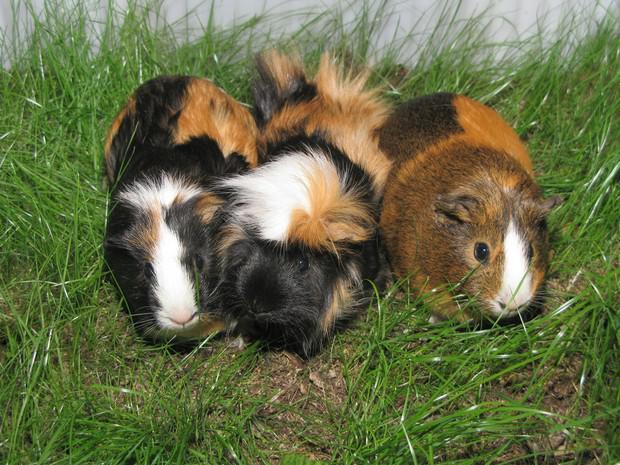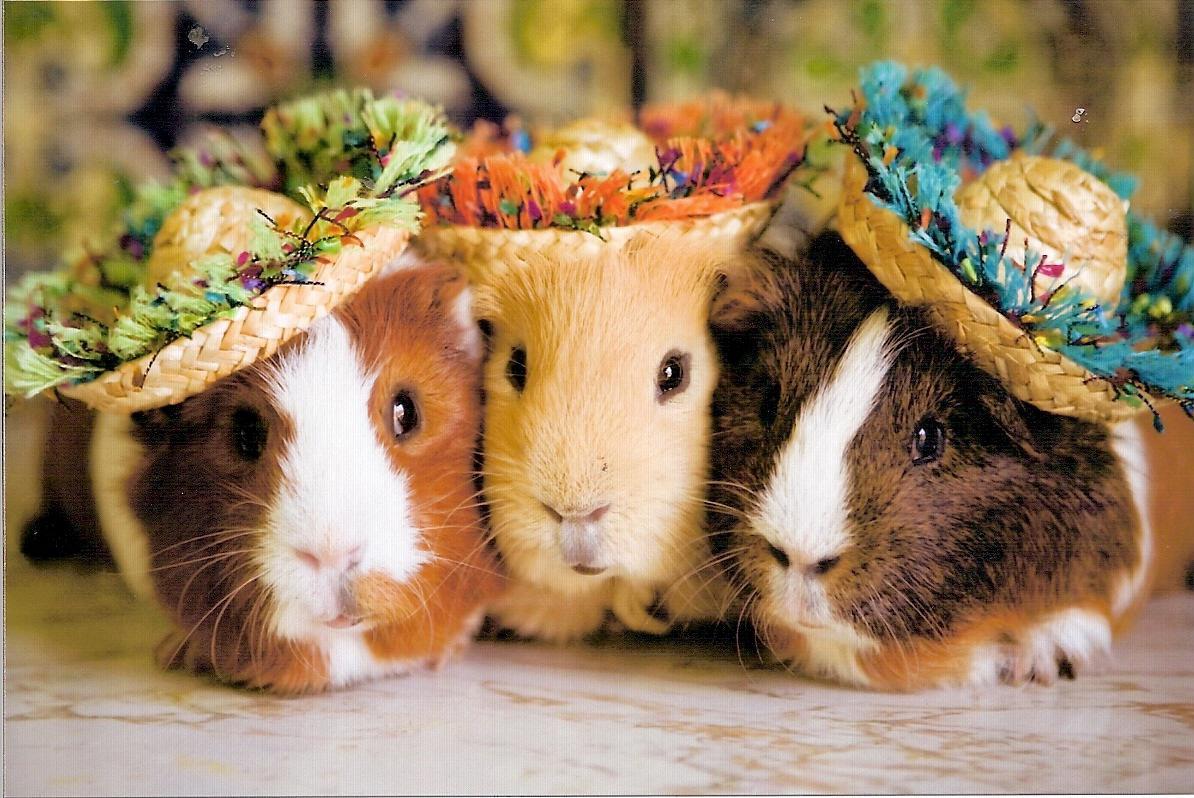The first image is the image on the left, the second image is the image on the right. Considering the images on both sides, is "An image shows a larger guinea pig with a smaller pet rodent on a fabric ground surface." valid? Answer yes or no. No. The first image is the image on the left, the second image is the image on the right. For the images shown, is this caption "The rodents in the image on the left are sitting on green grass." true? Answer yes or no. Yes. 